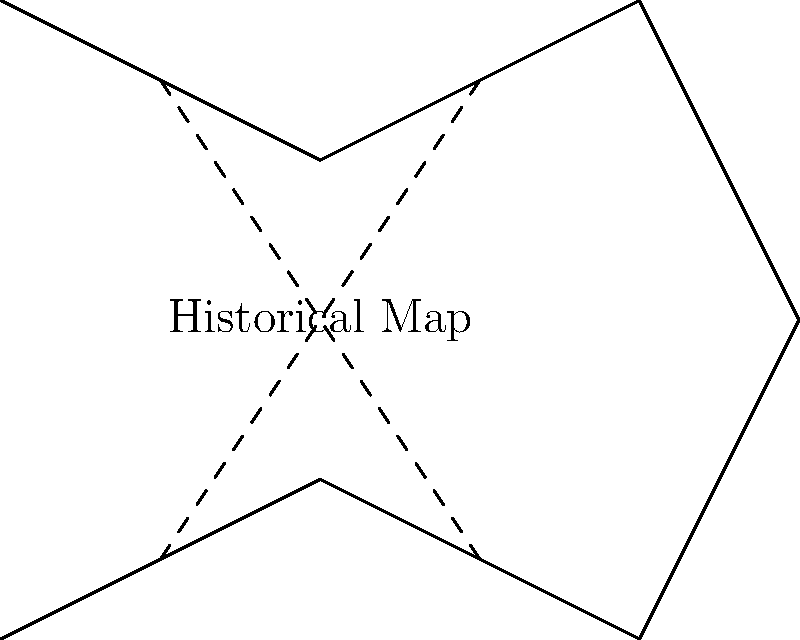In the context of historical map topology, what does the presence of intersecting dashed lines on this simplified map representation typically indicate? To answer this question, let's analyze the topological features of the given historical map representation:

1. The solid line represents the outline or boundary of a geographical area on a historical map.

2. The dashed lines intersecting within the map area are not typical geographical features but rather represent something else.

3. In the study of historical map topology:
   a) Maps often contain distortions due to limitations in surveying techniques, projection methods, or cultural biases.
   b) These distortions can affect distances, angles, or areas on the map.

4. Intersecting lines in topology often indicate areas of transformation or change.

5. In the context of historical maps, such intersecting lines typically represent:
   a) Areas where the map's accuracy is questionable
   b) Regions where different mapping techniques or projections meet
   c) Zones of cartographic distortion

6. These distortions are crucial in understanding the evolution of mapmaking and geographical knowledge over time.

7. For a principal supporting interdisciplinary learning, this concept bridges history (evolution of cartography) and mathematics (topology and geometry).

Therefore, the intersecting dashed lines on this simplified map representation typically indicate areas of cartographic distortion or uncertainty in historical maps.
Answer: Cartographic distortion 